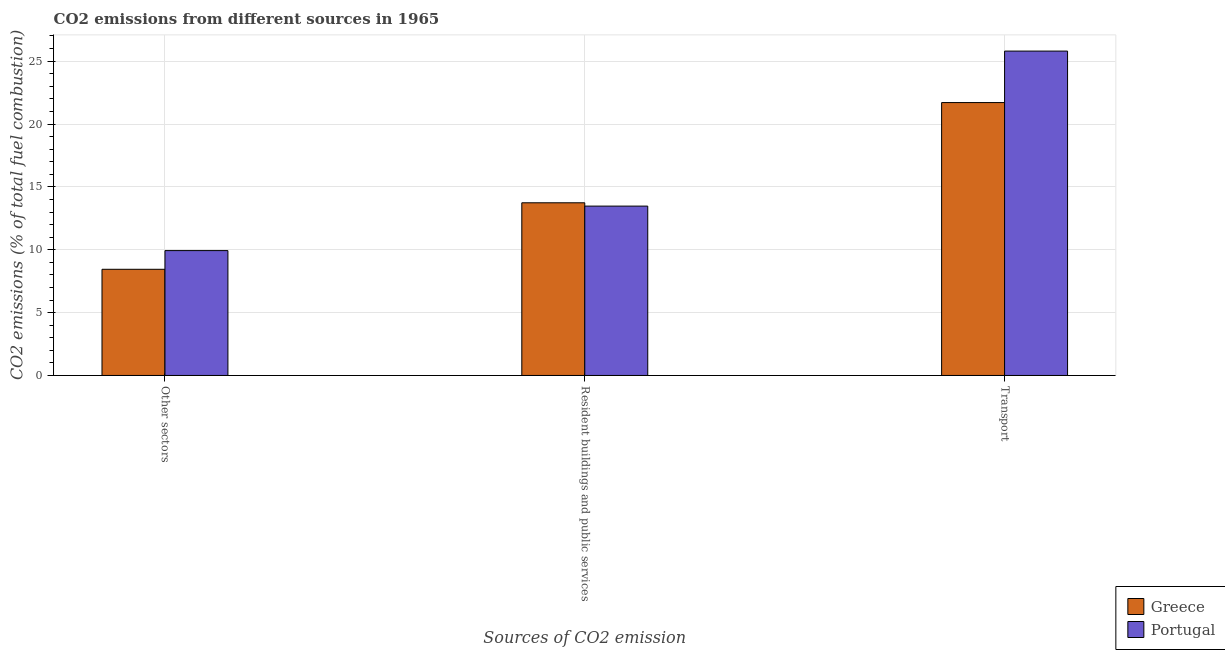How many groups of bars are there?
Offer a terse response. 3. Are the number of bars on each tick of the X-axis equal?
Give a very brief answer. Yes. What is the label of the 2nd group of bars from the left?
Your answer should be compact. Resident buildings and public services. What is the percentage of co2 emissions from resident buildings and public services in Portugal?
Offer a terse response. 13.47. Across all countries, what is the maximum percentage of co2 emissions from other sectors?
Give a very brief answer. 9.93. Across all countries, what is the minimum percentage of co2 emissions from other sectors?
Give a very brief answer. 8.45. In which country was the percentage of co2 emissions from other sectors maximum?
Your response must be concise. Portugal. What is the total percentage of co2 emissions from transport in the graph?
Your answer should be very brief. 47.5. What is the difference between the percentage of co2 emissions from transport in Portugal and that in Greece?
Provide a succinct answer. 4.09. What is the difference between the percentage of co2 emissions from transport in Greece and the percentage of co2 emissions from resident buildings and public services in Portugal?
Make the answer very short. 8.23. What is the average percentage of co2 emissions from resident buildings and public services per country?
Keep it short and to the point. 13.6. What is the difference between the percentage of co2 emissions from transport and percentage of co2 emissions from other sectors in Portugal?
Provide a short and direct response. 15.87. In how many countries, is the percentage of co2 emissions from other sectors greater than 21 %?
Your response must be concise. 0. What is the ratio of the percentage of co2 emissions from other sectors in Greece to that in Portugal?
Keep it short and to the point. 0.85. Is the percentage of co2 emissions from transport in Portugal less than that in Greece?
Your answer should be very brief. No. Is the difference between the percentage of co2 emissions from other sectors in Greece and Portugal greater than the difference between the percentage of co2 emissions from resident buildings and public services in Greece and Portugal?
Ensure brevity in your answer.  No. What is the difference between the highest and the second highest percentage of co2 emissions from transport?
Your answer should be compact. 4.09. What is the difference between the highest and the lowest percentage of co2 emissions from resident buildings and public services?
Provide a short and direct response. 0.26. In how many countries, is the percentage of co2 emissions from transport greater than the average percentage of co2 emissions from transport taken over all countries?
Your answer should be compact. 1. What does the 2nd bar from the right in Transport represents?
Offer a terse response. Greece. Is it the case that in every country, the sum of the percentage of co2 emissions from other sectors and percentage of co2 emissions from resident buildings and public services is greater than the percentage of co2 emissions from transport?
Keep it short and to the point. No. Are all the bars in the graph horizontal?
Provide a succinct answer. No. How many countries are there in the graph?
Your response must be concise. 2. Does the graph contain grids?
Your answer should be very brief. Yes. How are the legend labels stacked?
Give a very brief answer. Vertical. What is the title of the graph?
Keep it short and to the point. CO2 emissions from different sources in 1965. Does "Tunisia" appear as one of the legend labels in the graph?
Your answer should be compact. No. What is the label or title of the X-axis?
Provide a succinct answer. Sources of CO2 emission. What is the label or title of the Y-axis?
Your response must be concise. CO2 emissions (% of total fuel combustion). What is the CO2 emissions (% of total fuel combustion) of Greece in Other sectors?
Make the answer very short. 8.45. What is the CO2 emissions (% of total fuel combustion) of Portugal in Other sectors?
Make the answer very short. 9.93. What is the CO2 emissions (% of total fuel combustion) of Greece in Resident buildings and public services?
Offer a terse response. 13.73. What is the CO2 emissions (% of total fuel combustion) in Portugal in Resident buildings and public services?
Your response must be concise. 13.47. What is the CO2 emissions (% of total fuel combustion) of Greece in Transport?
Make the answer very short. 21.7. What is the CO2 emissions (% of total fuel combustion) of Portugal in Transport?
Your answer should be compact. 25.8. Across all Sources of CO2 emission, what is the maximum CO2 emissions (% of total fuel combustion) in Greece?
Your answer should be compact. 21.7. Across all Sources of CO2 emission, what is the maximum CO2 emissions (% of total fuel combustion) in Portugal?
Provide a short and direct response. 25.8. Across all Sources of CO2 emission, what is the minimum CO2 emissions (% of total fuel combustion) of Greece?
Offer a very short reply. 8.45. Across all Sources of CO2 emission, what is the minimum CO2 emissions (% of total fuel combustion) in Portugal?
Give a very brief answer. 9.93. What is the total CO2 emissions (% of total fuel combustion) of Greece in the graph?
Offer a terse response. 43.88. What is the total CO2 emissions (% of total fuel combustion) in Portugal in the graph?
Ensure brevity in your answer.  49.2. What is the difference between the CO2 emissions (% of total fuel combustion) in Greece in Other sectors and that in Resident buildings and public services?
Give a very brief answer. -5.29. What is the difference between the CO2 emissions (% of total fuel combustion) of Portugal in Other sectors and that in Resident buildings and public services?
Offer a very short reply. -3.54. What is the difference between the CO2 emissions (% of total fuel combustion) in Greece in Other sectors and that in Transport?
Offer a terse response. -13.26. What is the difference between the CO2 emissions (% of total fuel combustion) in Portugal in Other sectors and that in Transport?
Your response must be concise. -15.87. What is the difference between the CO2 emissions (% of total fuel combustion) in Greece in Resident buildings and public services and that in Transport?
Make the answer very short. -7.97. What is the difference between the CO2 emissions (% of total fuel combustion) in Portugal in Resident buildings and public services and that in Transport?
Offer a very short reply. -12.33. What is the difference between the CO2 emissions (% of total fuel combustion) of Greece in Other sectors and the CO2 emissions (% of total fuel combustion) of Portugal in Resident buildings and public services?
Your answer should be compact. -5.03. What is the difference between the CO2 emissions (% of total fuel combustion) in Greece in Other sectors and the CO2 emissions (% of total fuel combustion) in Portugal in Transport?
Your response must be concise. -17.35. What is the difference between the CO2 emissions (% of total fuel combustion) of Greece in Resident buildings and public services and the CO2 emissions (% of total fuel combustion) of Portugal in Transport?
Offer a very short reply. -12.07. What is the average CO2 emissions (% of total fuel combustion) of Greece per Sources of CO2 emission?
Provide a succinct answer. 14.63. What is the average CO2 emissions (% of total fuel combustion) of Portugal per Sources of CO2 emission?
Make the answer very short. 16.4. What is the difference between the CO2 emissions (% of total fuel combustion) in Greece and CO2 emissions (% of total fuel combustion) in Portugal in Other sectors?
Give a very brief answer. -1.49. What is the difference between the CO2 emissions (% of total fuel combustion) of Greece and CO2 emissions (% of total fuel combustion) of Portugal in Resident buildings and public services?
Your answer should be compact. 0.26. What is the difference between the CO2 emissions (% of total fuel combustion) in Greece and CO2 emissions (% of total fuel combustion) in Portugal in Transport?
Keep it short and to the point. -4.09. What is the ratio of the CO2 emissions (% of total fuel combustion) of Greece in Other sectors to that in Resident buildings and public services?
Offer a very short reply. 0.61. What is the ratio of the CO2 emissions (% of total fuel combustion) of Portugal in Other sectors to that in Resident buildings and public services?
Ensure brevity in your answer.  0.74. What is the ratio of the CO2 emissions (% of total fuel combustion) of Greece in Other sectors to that in Transport?
Give a very brief answer. 0.39. What is the ratio of the CO2 emissions (% of total fuel combustion) of Portugal in Other sectors to that in Transport?
Offer a very short reply. 0.39. What is the ratio of the CO2 emissions (% of total fuel combustion) of Greece in Resident buildings and public services to that in Transport?
Your answer should be very brief. 0.63. What is the ratio of the CO2 emissions (% of total fuel combustion) of Portugal in Resident buildings and public services to that in Transport?
Give a very brief answer. 0.52. What is the difference between the highest and the second highest CO2 emissions (% of total fuel combustion) of Greece?
Offer a terse response. 7.97. What is the difference between the highest and the second highest CO2 emissions (% of total fuel combustion) of Portugal?
Your response must be concise. 12.33. What is the difference between the highest and the lowest CO2 emissions (% of total fuel combustion) of Greece?
Keep it short and to the point. 13.26. What is the difference between the highest and the lowest CO2 emissions (% of total fuel combustion) of Portugal?
Your response must be concise. 15.87. 